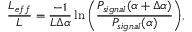<formula> <loc_0><loc_0><loc_500><loc_500>\frac { L _ { e f f } } { L } = \frac { - 1 } { L \Delta \alpha } \ln { \left ( \frac { P _ { s i g n a l } ( \alpha + \Delta \alpha ) } { P _ { s i g n a l } ( \alpha ) } \right ) } ,</formula> 